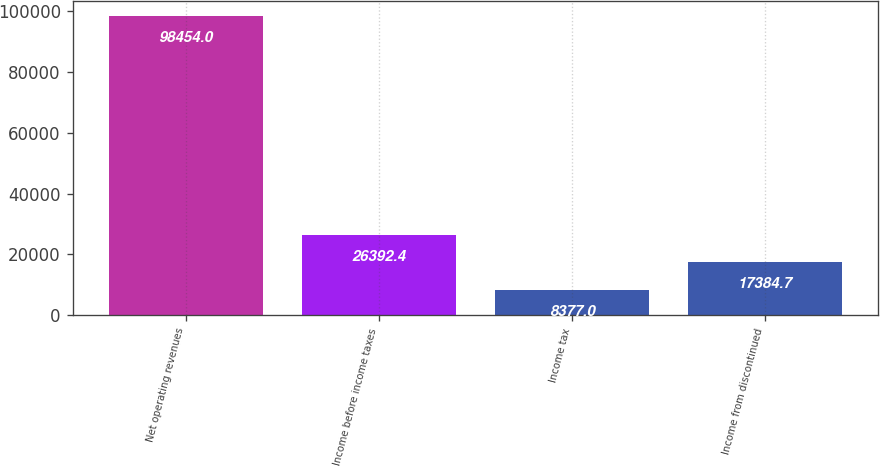Convert chart to OTSL. <chart><loc_0><loc_0><loc_500><loc_500><bar_chart><fcel>Net operating revenues<fcel>Income before income taxes<fcel>Income tax<fcel>Income from discontinued<nl><fcel>98454<fcel>26392.4<fcel>8377<fcel>17384.7<nl></chart> 